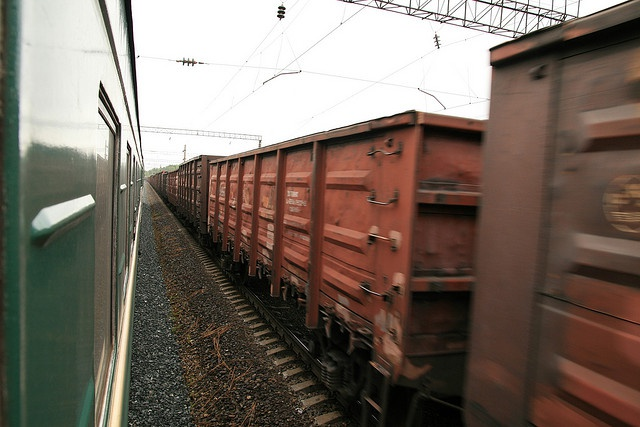Describe the objects in this image and their specific colors. I can see train in gray, maroon, and black tones and train in gray, ivory, darkgreen, and black tones in this image. 